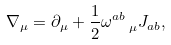Convert formula to latex. <formula><loc_0><loc_0><loc_500><loc_500>\nabla _ { \mu } = \partial _ { \mu } + \frac { 1 } { 2 } \omega _ { \text { \quad } \mu } ^ { a b } J _ { a b } ,</formula> 